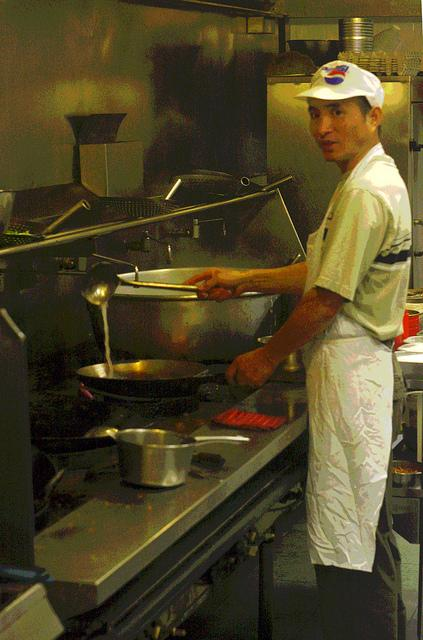What style food is most likely being prepared in this kitchen? Please explain your reasoning. chinese. Some chinese food served in restaurants are typically cooked in a wok, which is shown to be used by the chef here. 